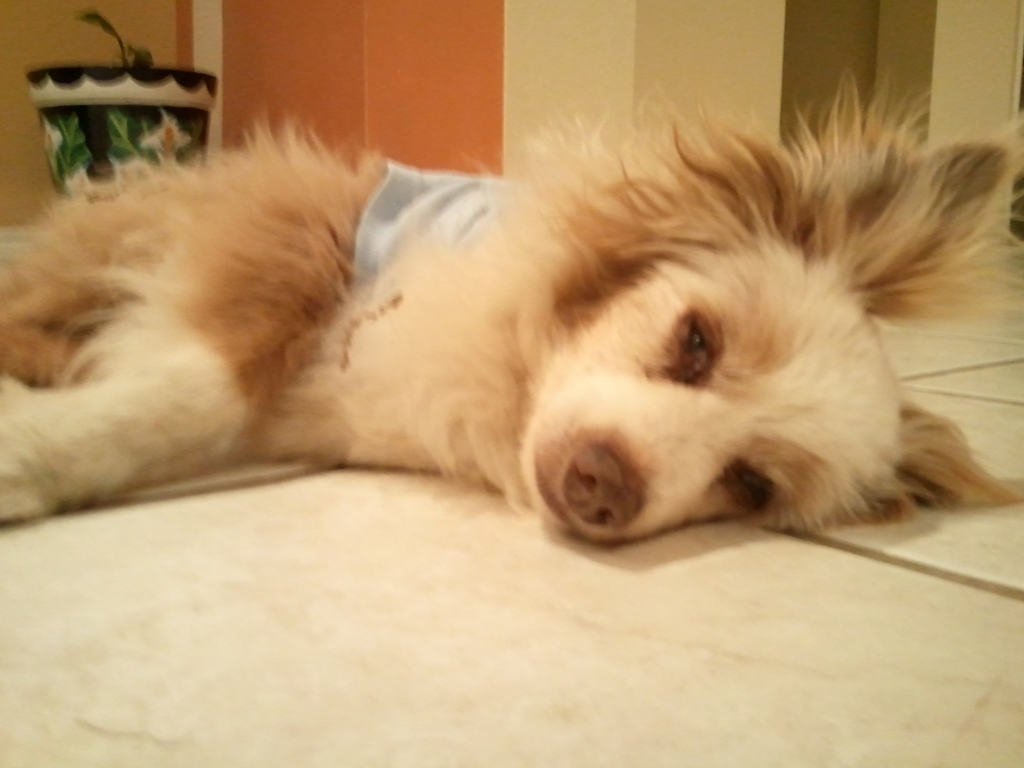Why is the picture considered acceptable?
A. The picture is acceptable because of its sharpness
B. The blurriness of the picture makes it unacceptable
C. Despite the blurriness, the overall quality is still satisfactory
Answer with the option's letter from the given choices directly.
 C. 